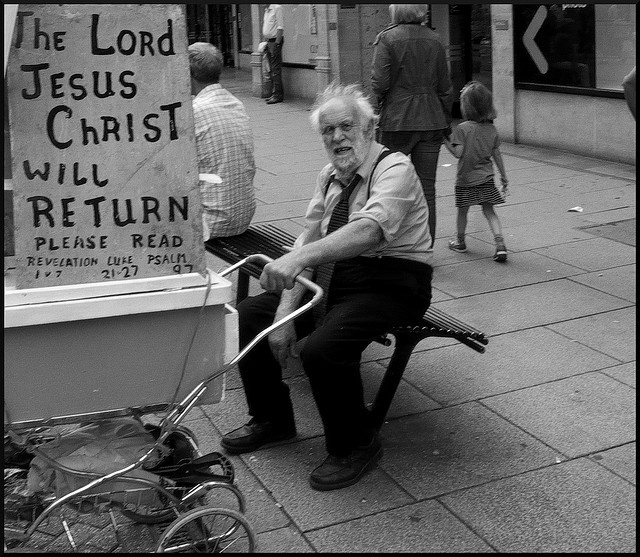Describe the objects in this image and their specific colors. I can see people in black, darkgray, gray, and lightgray tones, bicycle in black, gray, and white tones, people in black, gray, and silver tones, people in black, darkgray, gray, and lightgray tones, and bench in black, gray, darkgray, and lightgray tones in this image. 